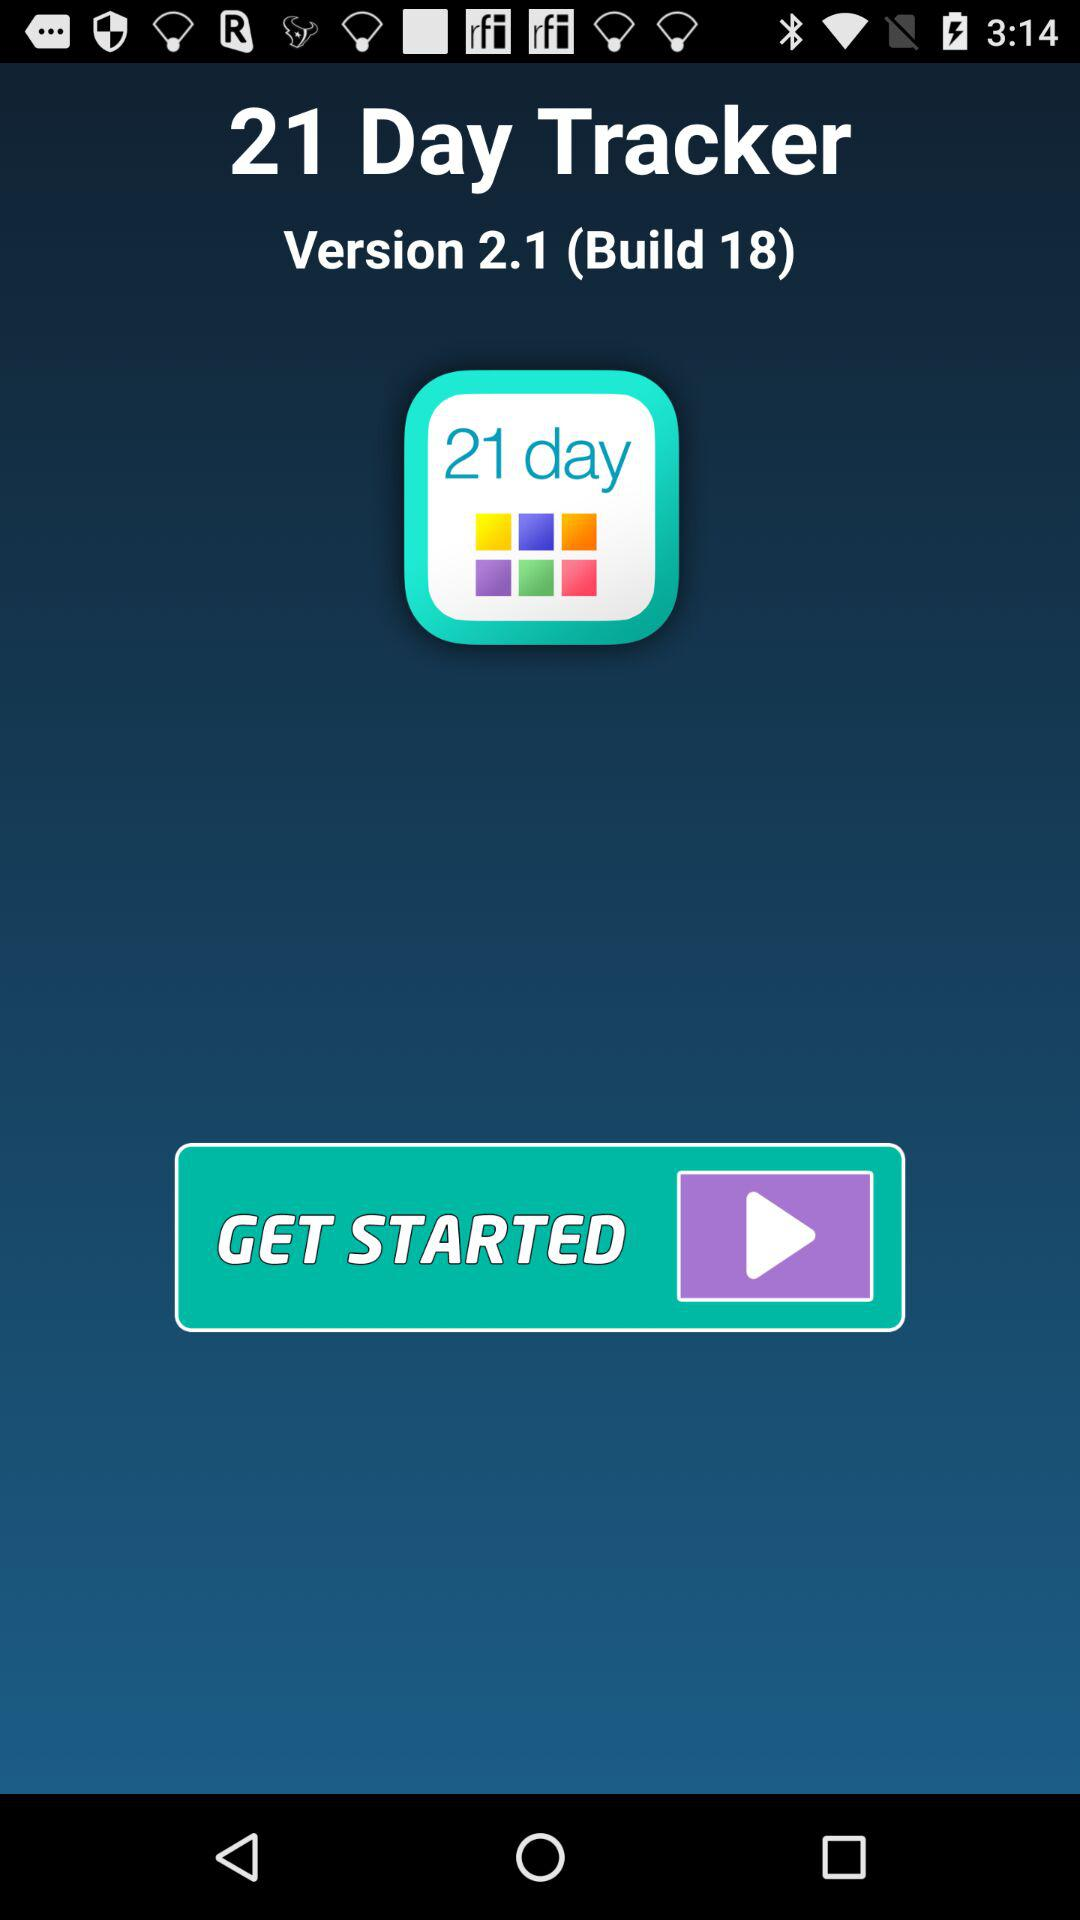What is the name of the application? The name of the application is "21 Day Tracker". 